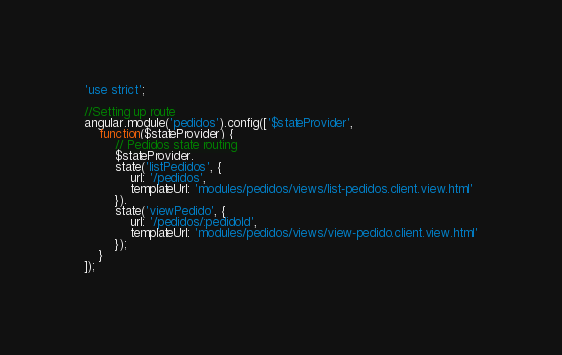Convert code to text. <code><loc_0><loc_0><loc_500><loc_500><_JavaScript_>'use strict';

//Setting up route
angular.module('pedidos').config(['$stateProvider',
	function($stateProvider) {
		// Pedidos state routing
		$stateProvider.
		state('listPedidos', {
			url: '/pedidos',
			templateUrl: 'modules/pedidos/views/list-pedidos.client.view.html'
		}).
		state('viewPedido', {
			url: '/pedidos/:pedidoId',
			templateUrl: 'modules/pedidos/views/view-pedido.client.view.html'
		});
	}
]);</code> 